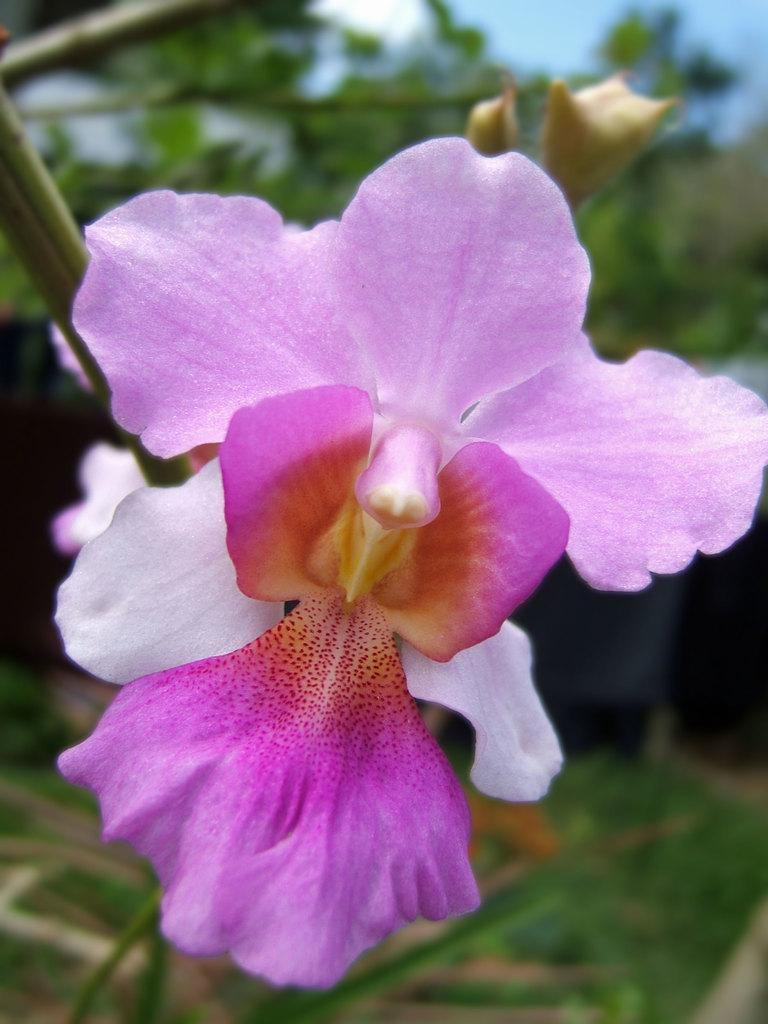What is the focus of the image? The image is zoomed in on a flower in the center. What can be seen in the background of the image? There are plants and the sky visible in the background. How many snakes are wrapped around the flower in the image? There are no snakes present in the image; it features a flower with plants and the sky in the background. What type of knot can be seen in the center of the flower? There is no knot present in the center of the flower; it is a natural flower. 